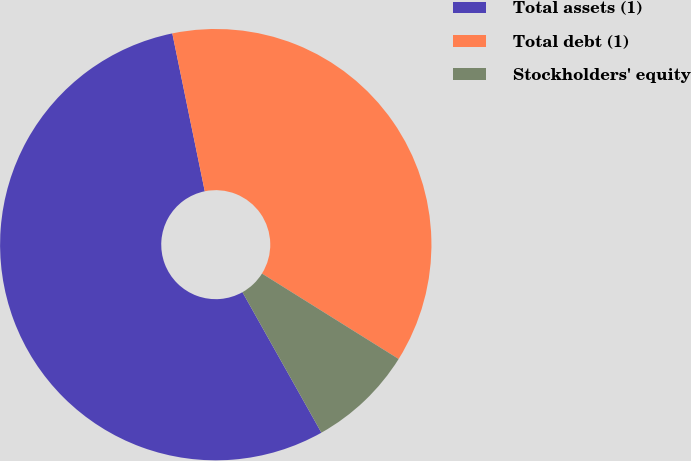Convert chart. <chart><loc_0><loc_0><loc_500><loc_500><pie_chart><fcel>Total assets (1)<fcel>Total debt (1)<fcel>Stockholders' equity<nl><fcel>54.92%<fcel>37.12%<fcel>7.96%<nl></chart> 